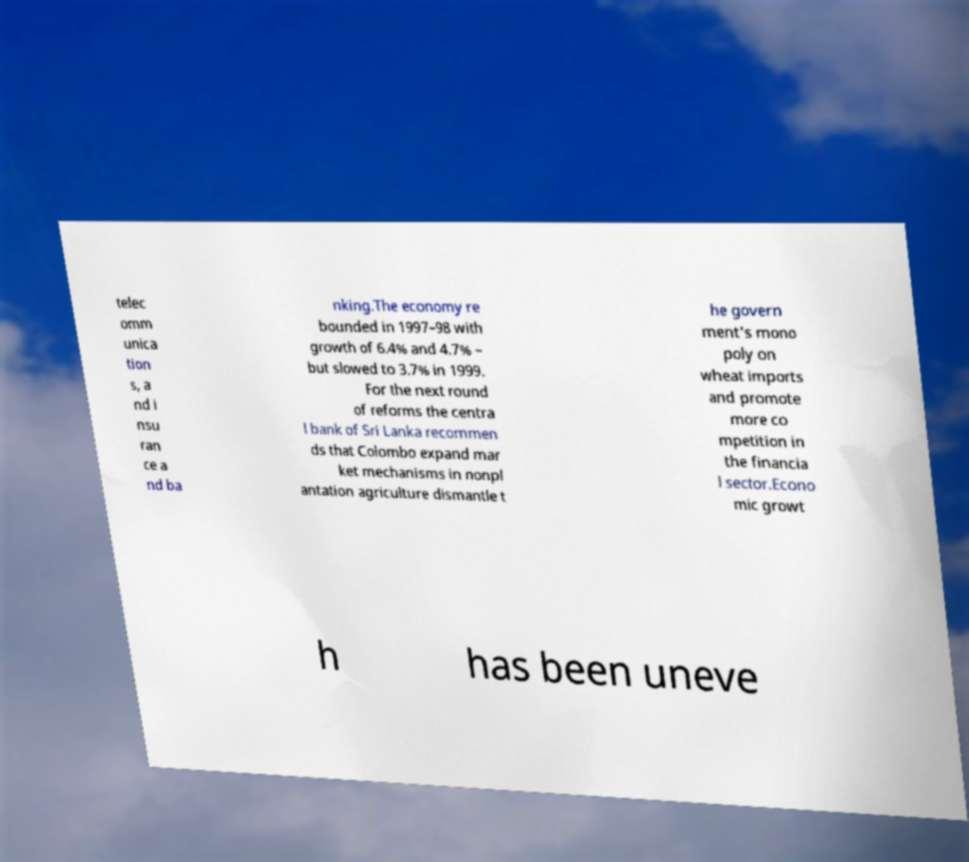I need the written content from this picture converted into text. Can you do that? telec omm unica tion s, a nd i nsu ran ce a nd ba nking.The economy re bounded in 1997–98 with growth of 6.4% and 4.7% – but slowed to 3.7% in 1999. For the next round of reforms the centra l bank of Sri Lanka recommen ds that Colombo expand mar ket mechanisms in nonpl antation agriculture dismantle t he govern ment's mono poly on wheat imports and promote more co mpetition in the financia l sector.Econo mic growt h has been uneve 